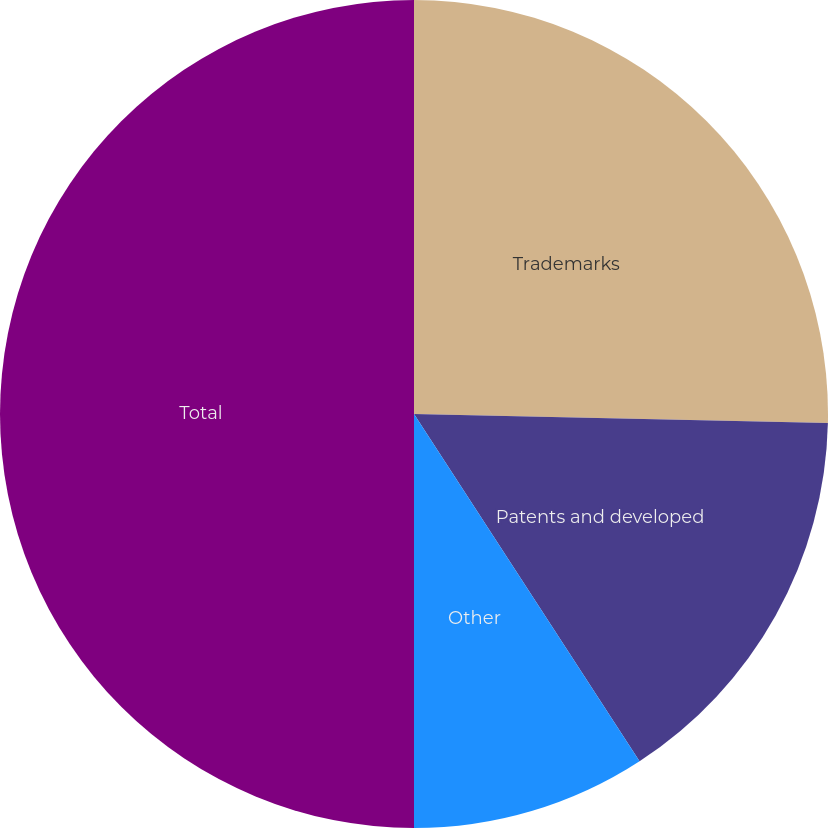Convert chart to OTSL. <chart><loc_0><loc_0><loc_500><loc_500><pie_chart><fcel>Trademarks<fcel>Patents and developed<fcel>Other<fcel>Total<nl><fcel>25.35%<fcel>15.48%<fcel>9.17%<fcel>50.0%<nl></chart> 